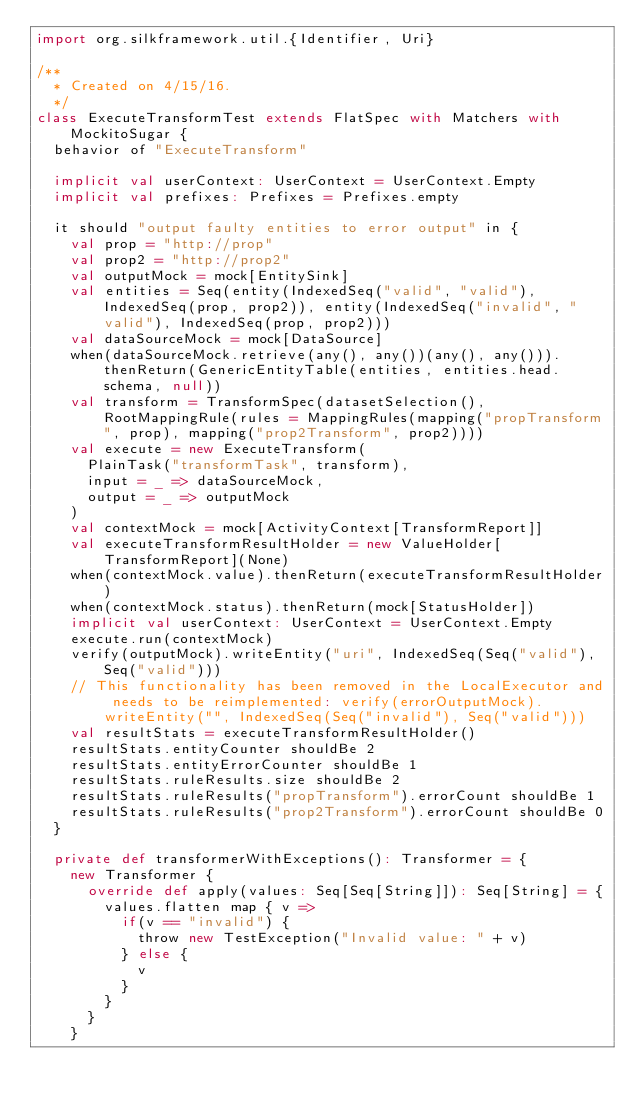Convert code to text. <code><loc_0><loc_0><loc_500><loc_500><_Scala_>import org.silkframework.util.{Identifier, Uri}

/**
  * Created on 4/15/16.
  */
class ExecuteTransformTest extends FlatSpec with Matchers with MockitoSugar {
  behavior of "ExecuteTransform"

  implicit val userContext: UserContext = UserContext.Empty
  implicit val prefixes: Prefixes = Prefixes.empty

  it should "output faulty entities to error output" in {
    val prop = "http://prop"
    val prop2 = "http://prop2"
    val outputMock = mock[EntitySink]
    val entities = Seq(entity(IndexedSeq("valid", "valid"), IndexedSeq(prop, prop2)), entity(IndexedSeq("invalid", "valid"), IndexedSeq(prop, prop2)))
    val dataSourceMock = mock[DataSource]
    when(dataSourceMock.retrieve(any(), any())(any(), any())).thenReturn(GenericEntityTable(entities, entities.head.schema, null))
    val transform = TransformSpec(datasetSelection(), RootMappingRule(rules = MappingRules(mapping("propTransform", prop), mapping("prop2Transform", prop2))))
    val execute = new ExecuteTransform(
      PlainTask("transformTask", transform),
      input = _ => dataSourceMock,
      output = _ => outputMock
    )
    val contextMock = mock[ActivityContext[TransformReport]]
    val executeTransformResultHolder = new ValueHolder[TransformReport](None)
    when(contextMock.value).thenReturn(executeTransformResultHolder)
    when(contextMock.status).thenReturn(mock[StatusHolder])
    implicit val userContext: UserContext = UserContext.Empty
    execute.run(contextMock)
    verify(outputMock).writeEntity("uri", IndexedSeq(Seq("valid"), Seq("valid")))
    // This functionality has been removed in the LocalExecutor and needs to be reimplemented: verify(errorOutputMock).writeEntity("", IndexedSeq(Seq("invalid"), Seq("valid")))
    val resultStats = executeTransformResultHolder()
    resultStats.entityCounter shouldBe 2
    resultStats.entityErrorCounter shouldBe 1
    resultStats.ruleResults.size shouldBe 2
    resultStats.ruleResults("propTransform").errorCount shouldBe 1
    resultStats.ruleResults("prop2Transform").errorCount shouldBe 0
  }

  private def transformerWithExceptions(): Transformer = {
    new Transformer {
      override def apply(values: Seq[Seq[String]]): Seq[String] = {
        values.flatten map { v =>
          if(v == "invalid") {
            throw new TestException("Invalid value: " + v)
          } else {
            v
          }
        }
      }
    }</code> 